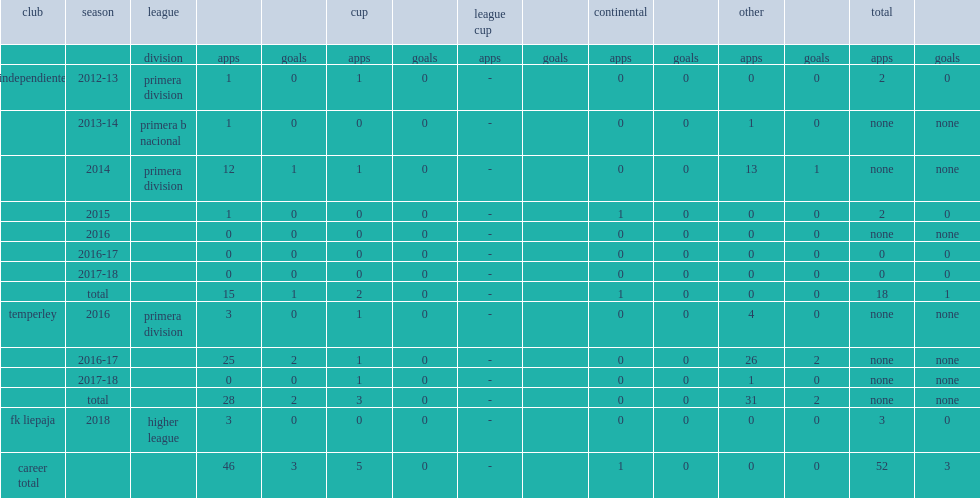In 2018, which league did zarate join side fk liepaja? Higher league. 